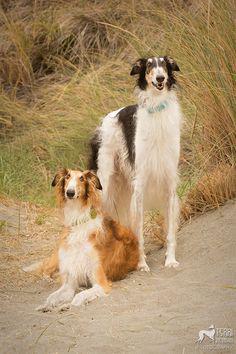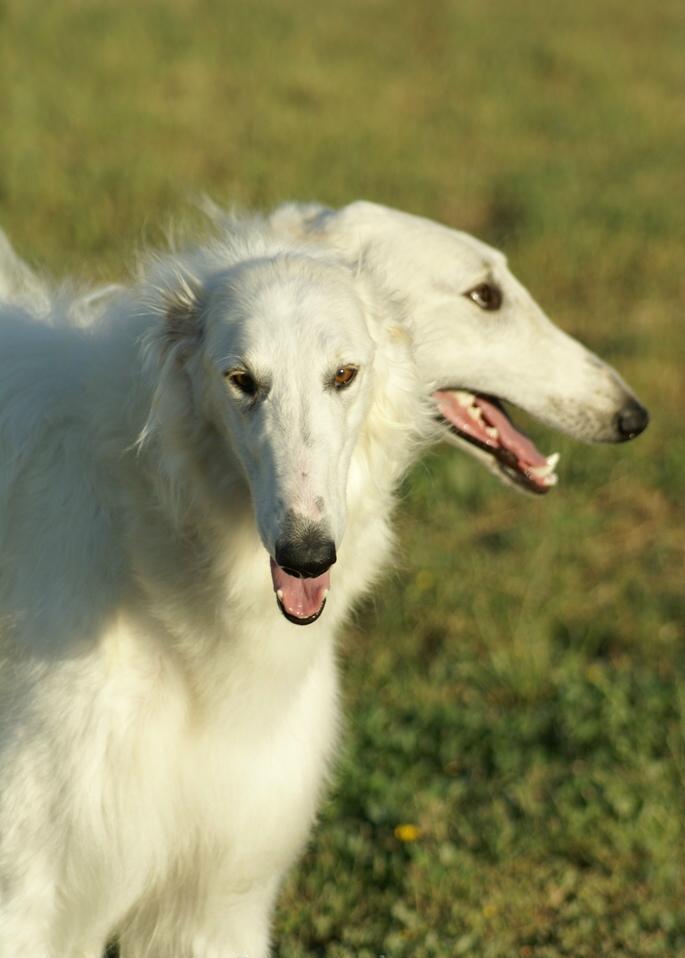The first image is the image on the left, the second image is the image on the right. For the images shown, is this caption "An image shows two hounds with faces turned inward, toward each other, and one with its head above the other." true? Answer yes or no. No. The first image is the image on the left, the second image is the image on the right. Analyze the images presented: Is the assertion "Two dogs are running together in a field of grass." valid? Answer yes or no. No. 